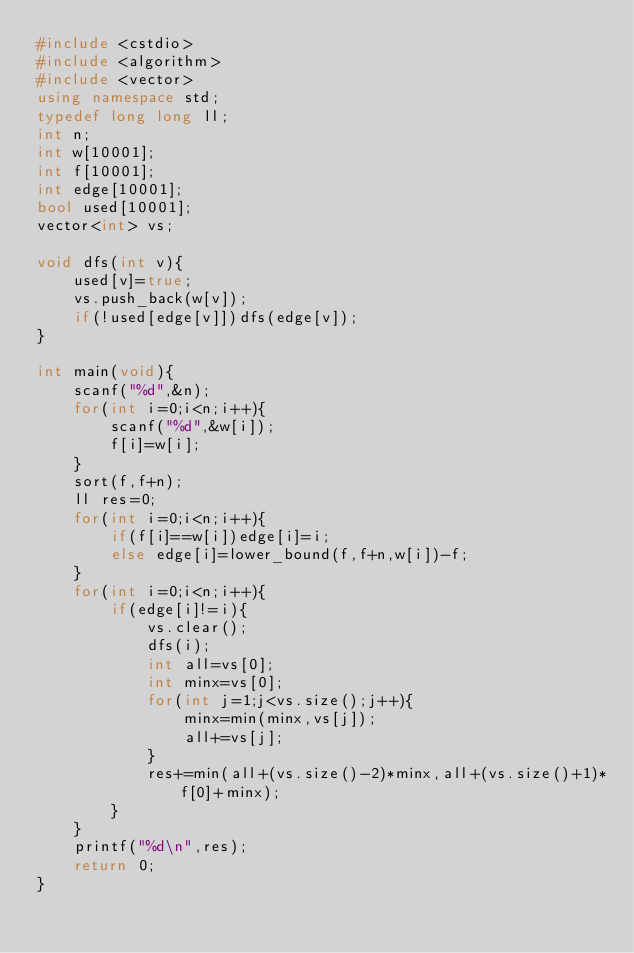Convert code to text. <code><loc_0><loc_0><loc_500><loc_500><_C++_>#include <cstdio>
#include <algorithm>
#include <vector>
using namespace std;
typedef long long ll;
int n;
int w[10001];
int f[10001];
int edge[10001];
bool used[10001];
vector<int> vs;

void dfs(int v){
	used[v]=true;
	vs.push_back(w[v]);
	if(!used[edge[v]])dfs(edge[v]);
}

int main(void){
	scanf("%d",&n);
	for(int i=0;i<n;i++){
		scanf("%d",&w[i]);
		f[i]=w[i];
	}
	sort(f,f+n);
	ll res=0;
	for(int i=0;i<n;i++){
		if(f[i]==w[i])edge[i]=i;
		else edge[i]=lower_bound(f,f+n,w[i])-f;
	}
	for(int i=0;i<n;i++){
		if(edge[i]!=i){
			vs.clear();
			dfs(i);
			int all=vs[0];
			int minx=vs[0];
			for(int j=1;j<vs.size();j++){
				minx=min(minx,vs[j]);
				all+=vs[j];
			}
			res+=min(all+(vs.size()-2)*minx,all+(vs.size()+1)*f[0]+minx);
		}
	}
	printf("%d\n",res);
	return 0;
}</code> 